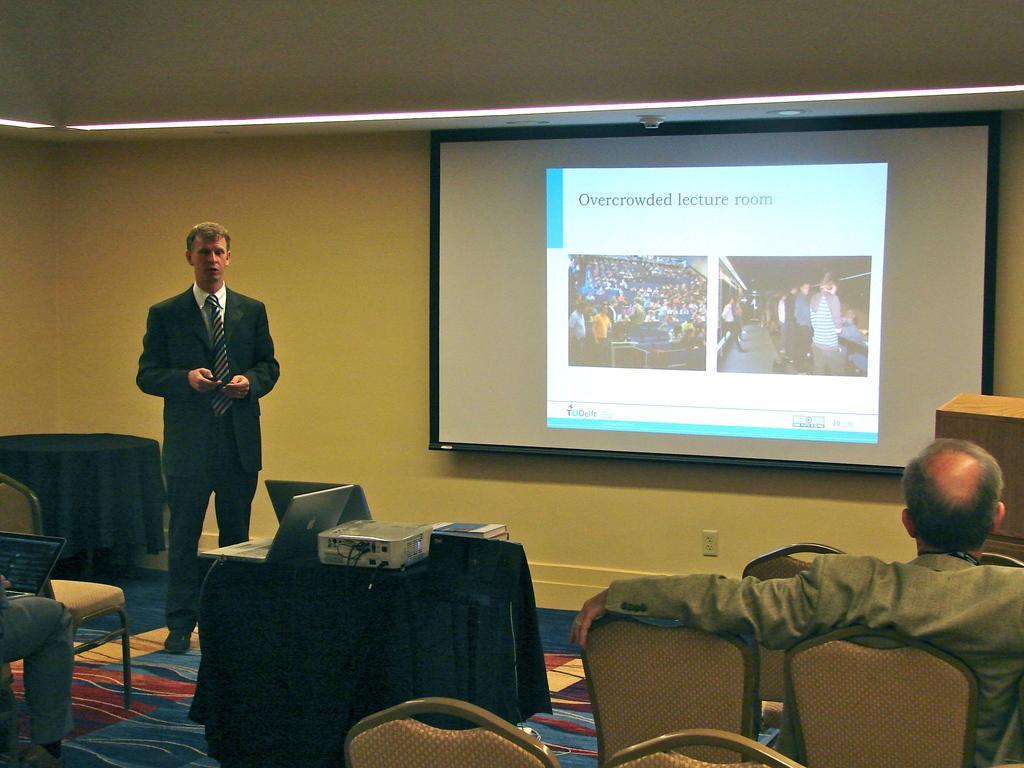Please provide a concise description of this image. In this image we can see a person standing and talking and there is a table and on the table we can see two laptops, projector and some other things. We can see a person sitting on the left side holding laptop and there is an another person on the right side of the image and we can see some chairs. There is a wall with a projector screen and on the screen we can see some pictures. 